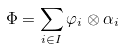<formula> <loc_0><loc_0><loc_500><loc_500>\Phi = \sum _ { i \in I } \varphi _ { i } \otimes \alpha _ { i }</formula> 